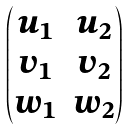Convert formula to latex. <formula><loc_0><loc_0><loc_500><loc_500>\begin{pmatrix} u _ { 1 } & u _ { 2 } \\ v _ { 1 } & v _ { 2 } \\ w _ { 1 } & w _ { 2 } \end{pmatrix}</formula> 